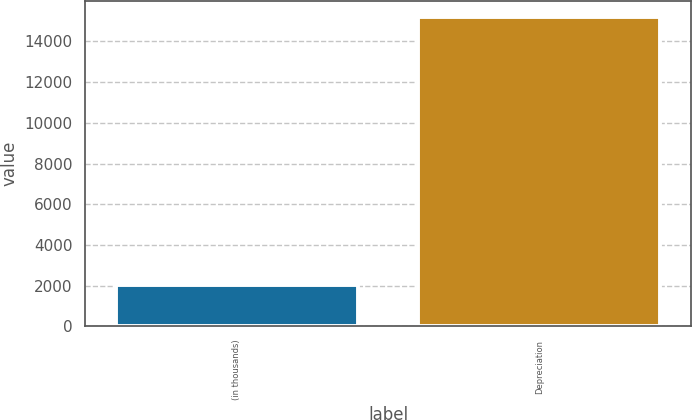Convert chart. <chart><loc_0><loc_0><loc_500><loc_500><bar_chart><fcel>(in thousands)<fcel>Depreciation<nl><fcel>2012<fcel>15212<nl></chart> 